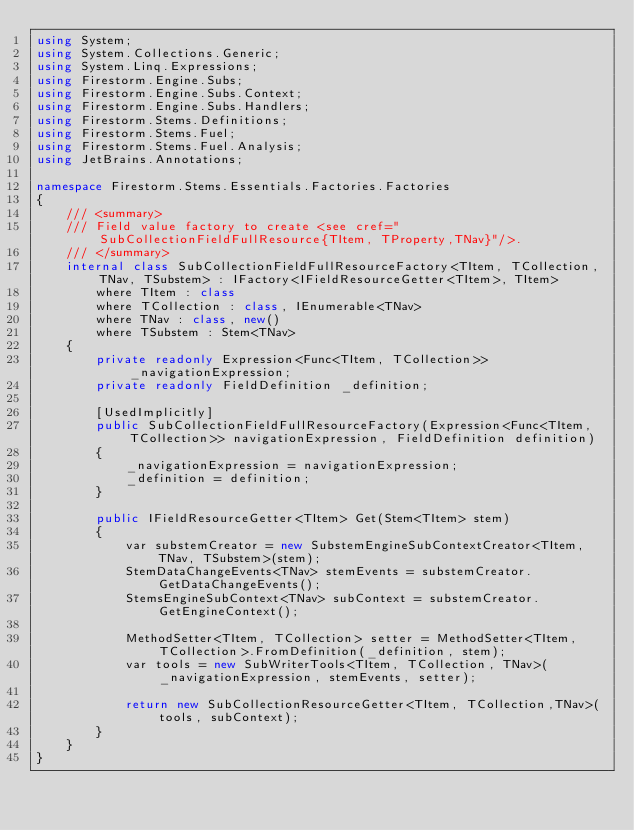<code> <loc_0><loc_0><loc_500><loc_500><_C#_>using System;
using System.Collections.Generic;
using System.Linq.Expressions;
using Firestorm.Engine.Subs;
using Firestorm.Engine.Subs.Context;
using Firestorm.Engine.Subs.Handlers;
using Firestorm.Stems.Definitions;
using Firestorm.Stems.Fuel;
using Firestorm.Stems.Fuel.Analysis;
using JetBrains.Annotations;

namespace Firestorm.Stems.Essentials.Factories.Factories
{
    /// <summary>
    /// Field value factory to create <see cref="SubCollectionFieldFullResource{TItem, TProperty,TNav}"/>.
    /// </summary>
    internal class SubCollectionFieldFullResourceFactory<TItem, TCollection, TNav, TSubstem> : IFactory<IFieldResourceGetter<TItem>, TItem>
        where TItem : class
        where TCollection : class, IEnumerable<TNav>
        where TNav : class, new()
        where TSubstem : Stem<TNav>
    {
        private readonly Expression<Func<TItem, TCollection>> _navigationExpression;
        private readonly FieldDefinition _definition;

        [UsedImplicitly]
        public SubCollectionFieldFullResourceFactory(Expression<Func<TItem, TCollection>> navigationExpression, FieldDefinition definition)
        {
            _navigationExpression = navigationExpression;
            _definition = definition;
        }

        public IFieldResourceGetter<TItem> Get(Stem<TItem> stem)
        {
            var substemCreator = new SubstemEngineSubContextCreator<TItem, TNav, TSubstem>(stem);
            StemDataChangeEvents<TNav> stemEvents = substemCreator.GetDataChangeEvents();
            StemsEngineSubContext<TNav> subContext = substemCreator.GetEngineContext();

            MethodSetter<TItem, TCollection> setter = MethodSetter<TItem, TCollection>.FromDefinition(_definition, stem);
            var tools = new SubWriterTools<TItem, TCollection, TNav>(_navigationExpression, stemEvents, setter);

            return new SubCollectionResourceGetter<TItem, TCollection,TNav>(tools, subContext);
        }
    }
}</code> 